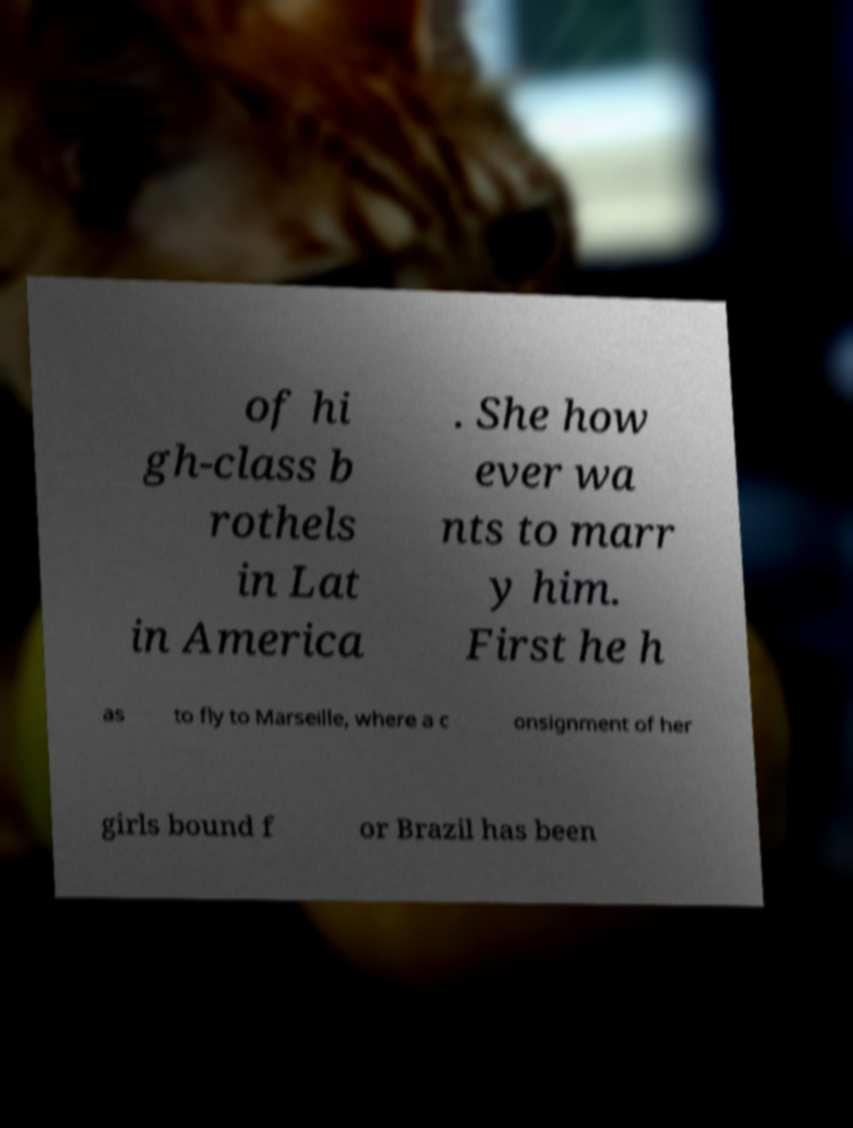For documentation purposes, I need the text within this image transcribed. Could you provide that? of hi gh-class b rothels in Lat in America . She how ever wa nts to marr y him. First he h as to fly to Marseille, where a c onsignment of her girls bound f or Brazil has been 